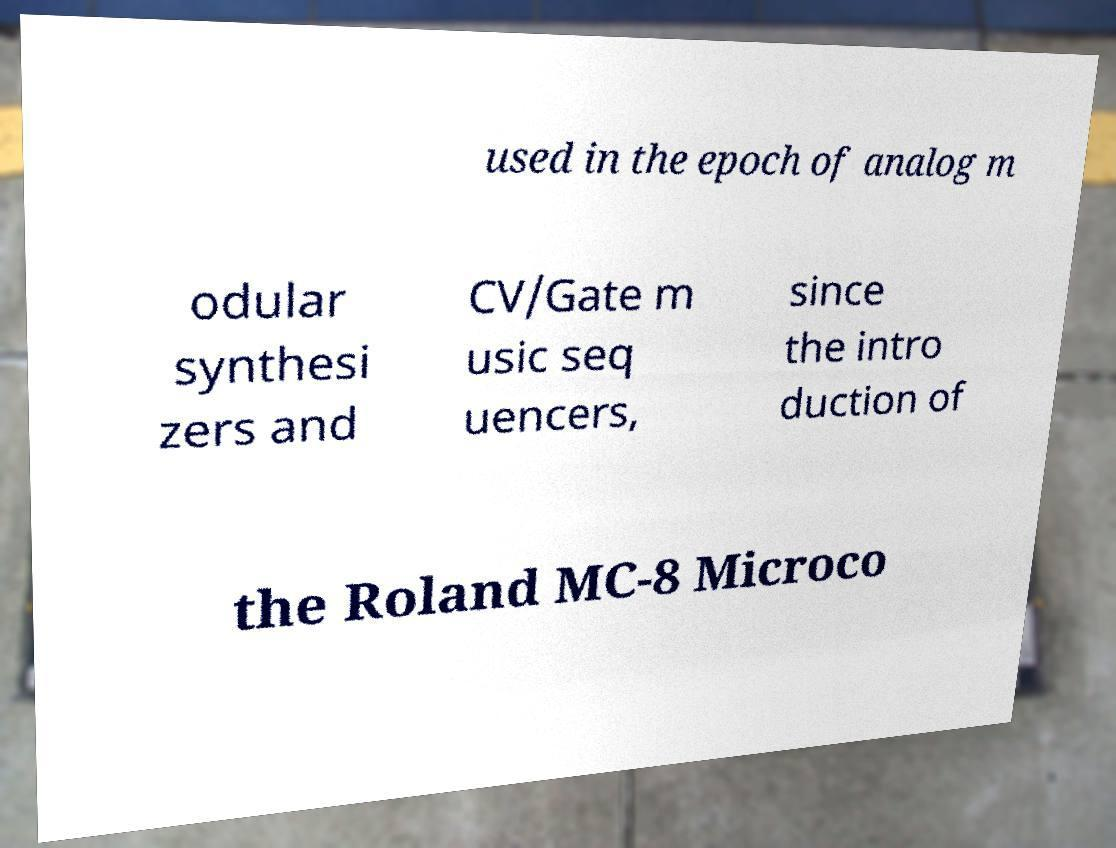What messages or text are displayed in this image? I need them in a readable, typed format. used in the epoch of analog m odular synthesi zers and CV/Gate m usic seq uencers, since the intro duction of the Roland MC-8 Microco 